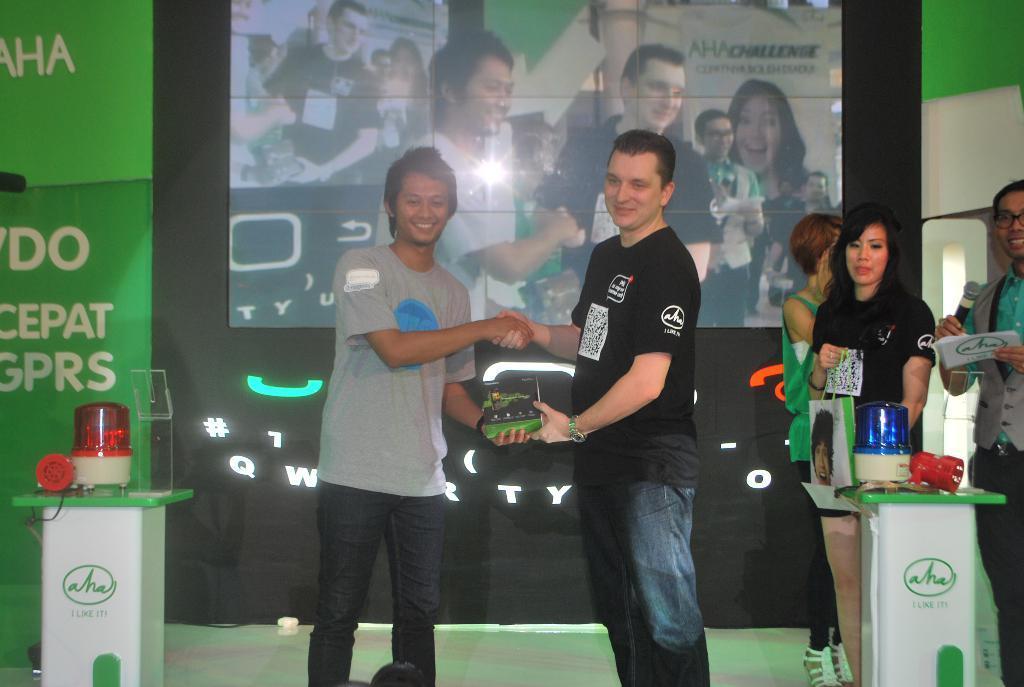Describe this image in one or two sentences. Here in this picture in the middle we can see two persons standing and the person on the left side is receiving a gift from the other person and beside them also we can see a group of people standing with a microphone in their hands and we can see tables on either side of them with lights on it present over there and behind them we can see a digital screen and on either side we can see banners present. 